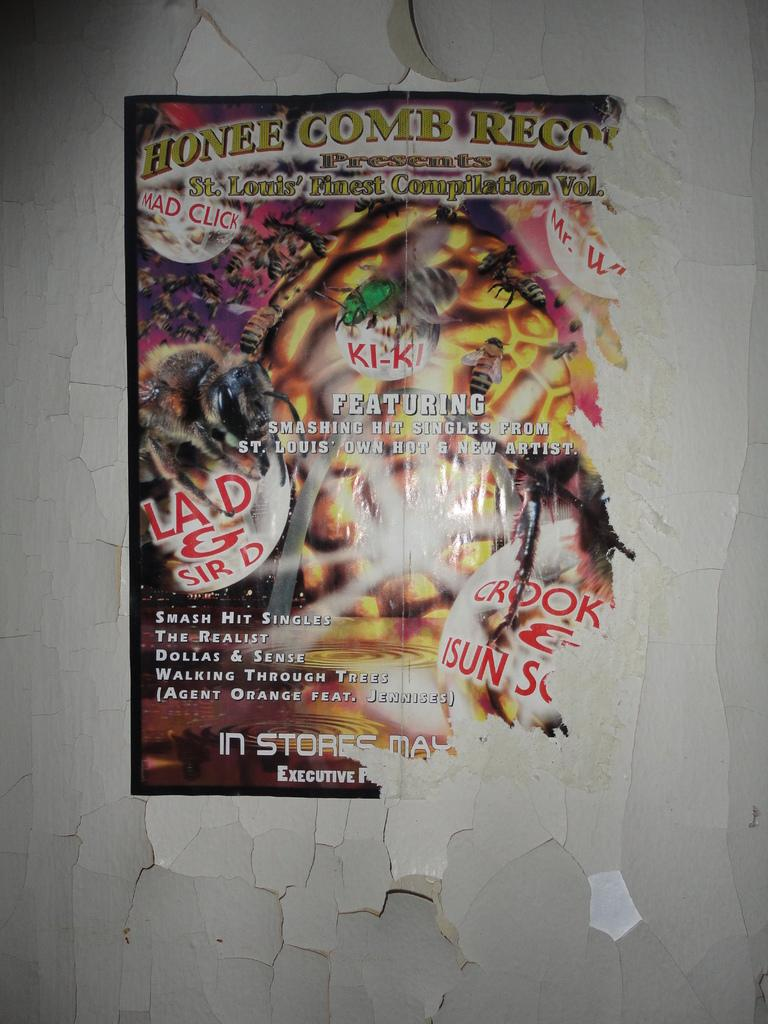<image>
Provide a brief description of the given image. A poster of sorts saying Honee Comb at the top. 